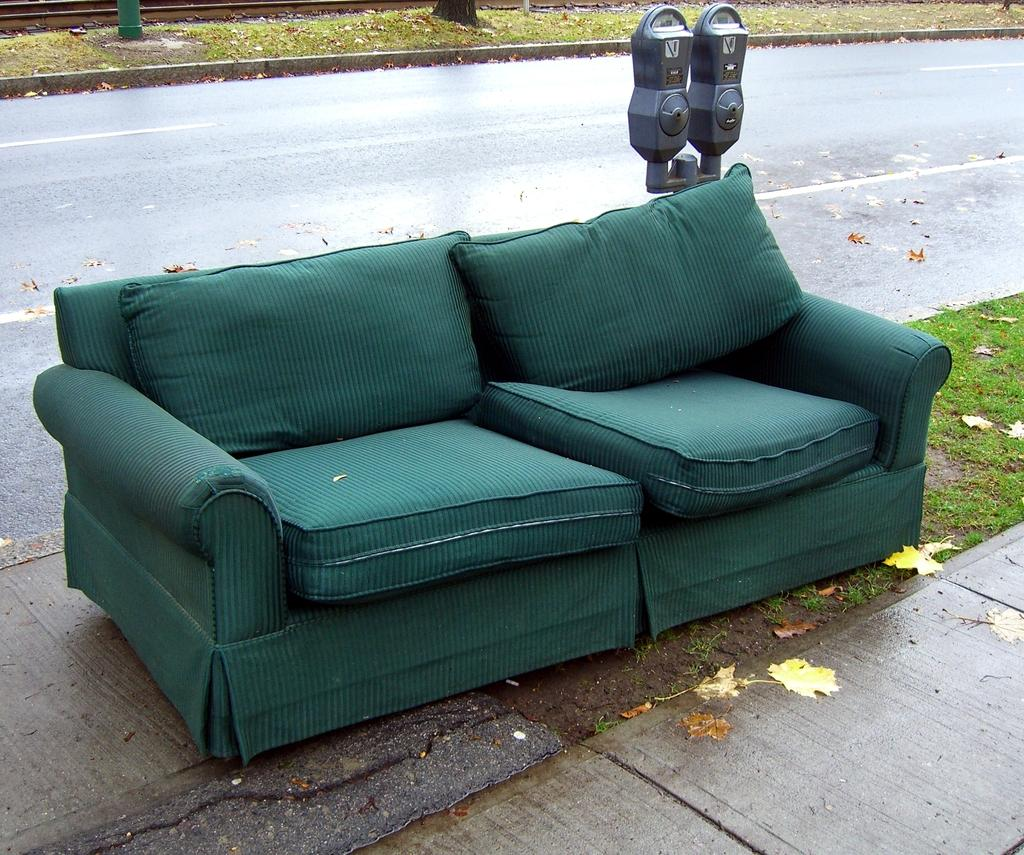What is located in the foreground of the image? There is a sofa and an object in the foreground of the image. Can you describe the object in the foreground? Unfortunately, the facts provided do not give a description of the object in the foreground. What can be seen in the background of the image? There is a road and grassland in the background of the image. How many locks are visible on the sofa in the image? There is no mention of locks in the image, as the facts provided only mention a sofa and an object in the foreground, as well as a road and grassland in the background. 